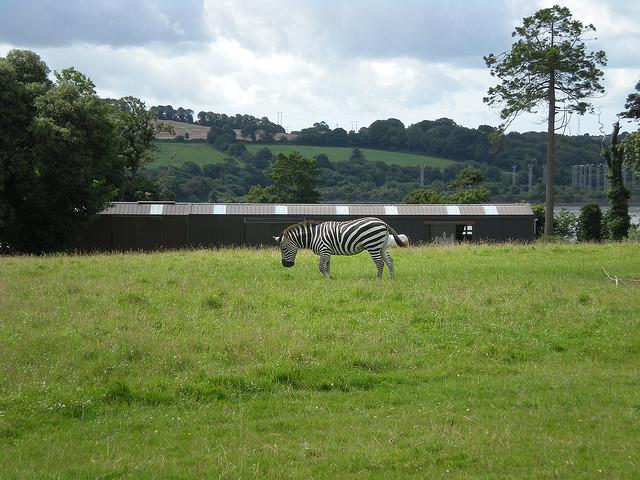Was the picture taken in the animal's natural habitat?
Short answer required. No. Is there mud on the ground?
Concise answer only. No. What is this animal?
Answer briefly. Zebra. How many animals are seen?
Short answer required. 1. Is the zebra grazing?
Write a very short answer. Yes. 